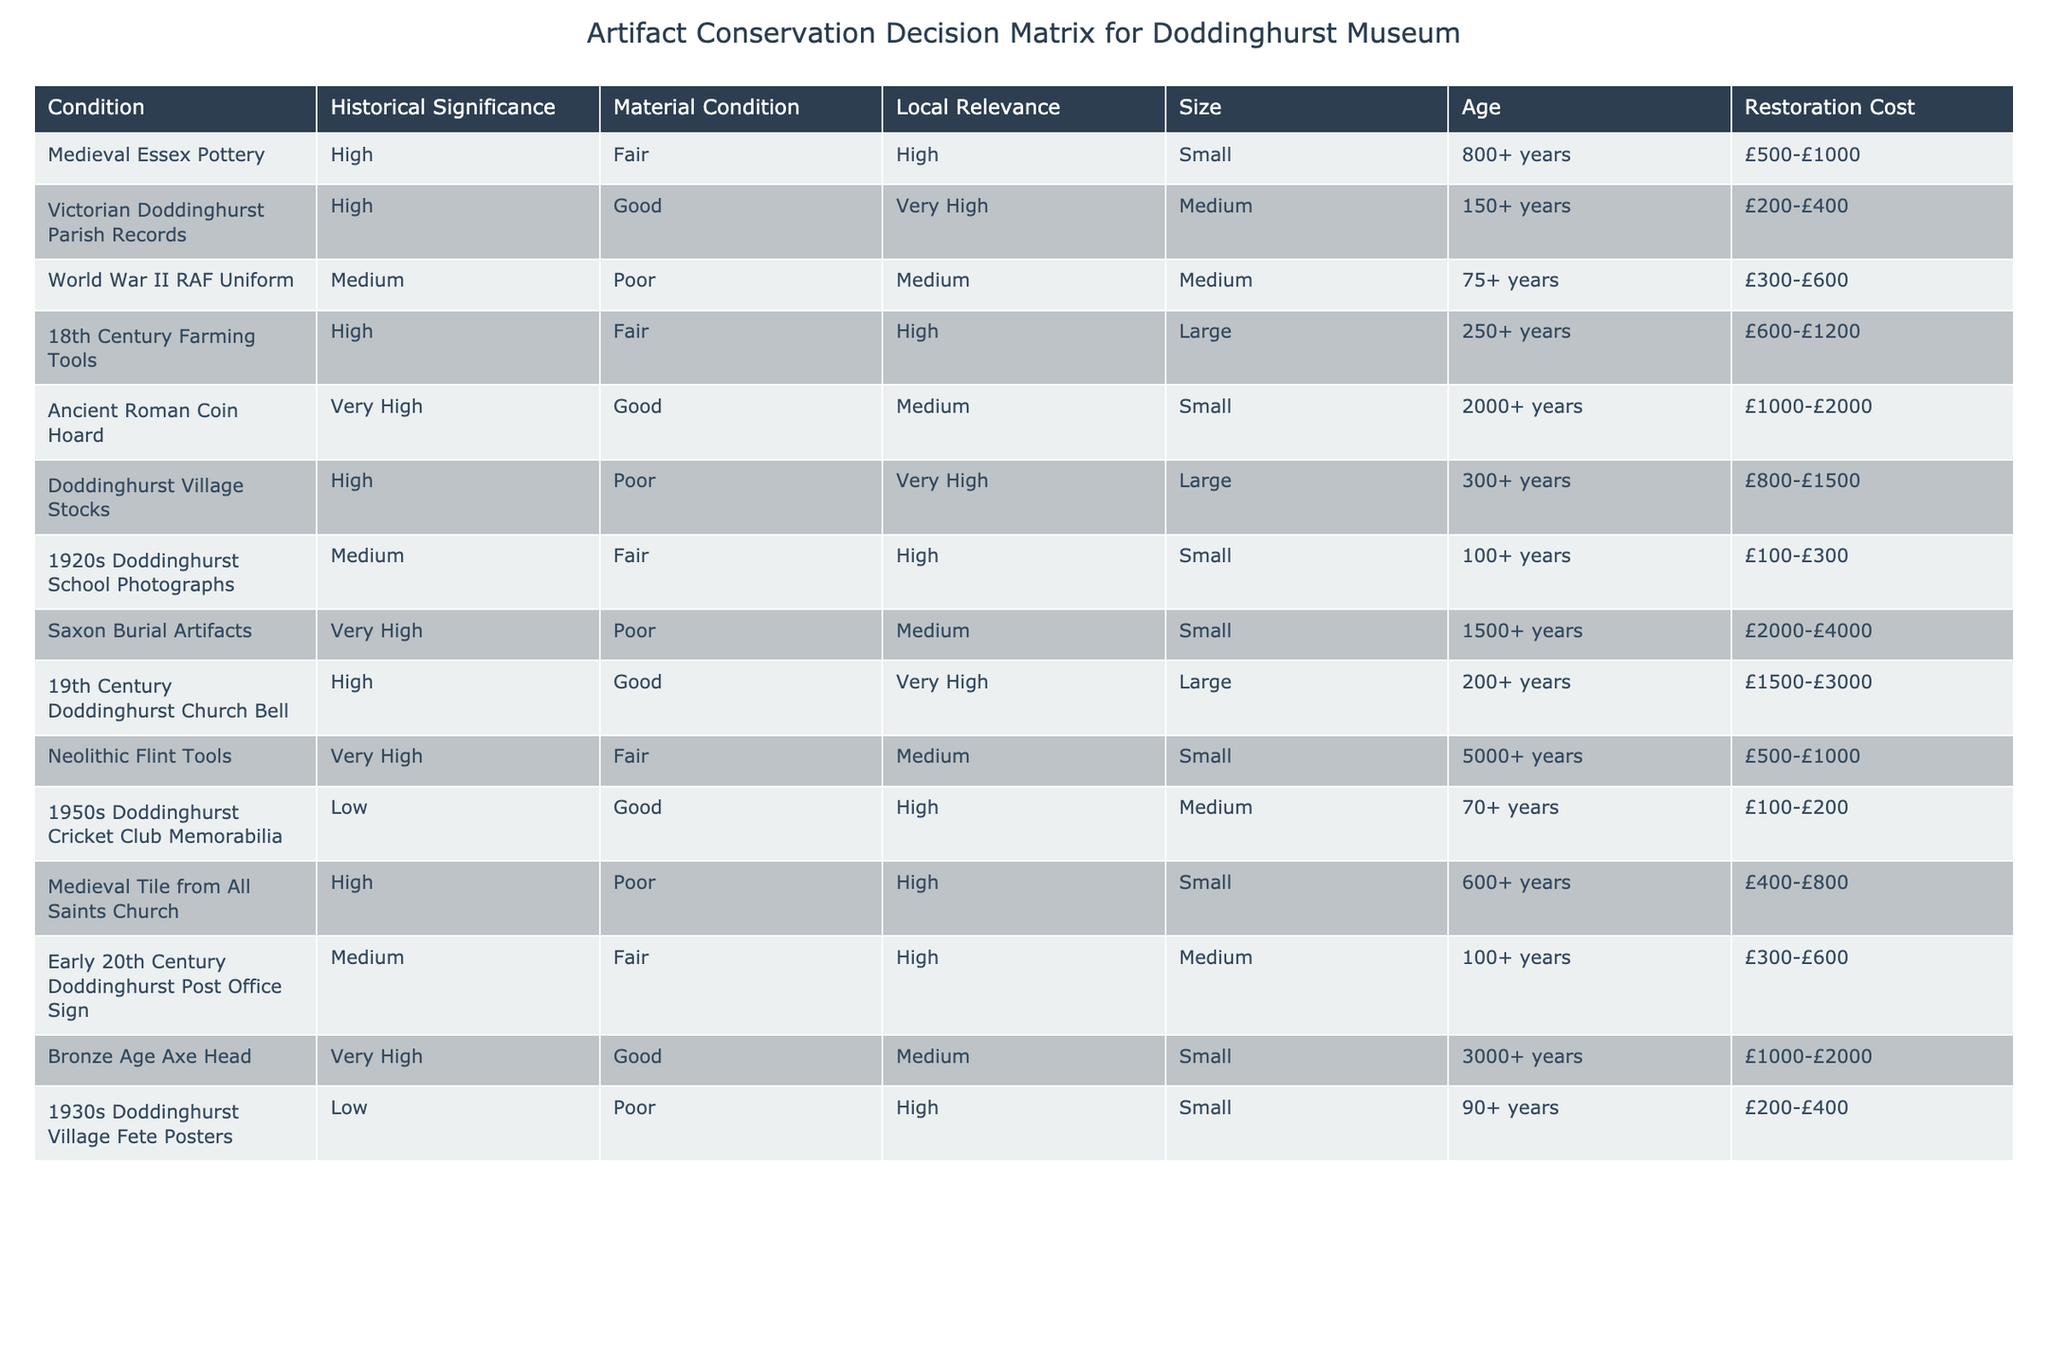What is the age of the Ancient Roman Coin Hoard? The age of the Ancient Roman Coin Hoard is listed as 2000+ years in the Age column.
Answer: 2000+ years Which artifact has the highest historical significance? The artifact with the highest historical significance is the Ancient Roman Coin Hoard, as it is categorized as Very High in the Historical Significance column.
Answer: Ancient Roman Coin Hoard What is the restoration cost range for the Doddinghurst Village Stocks? The restoration cost range for the Doddinghurst Village Stocks is £800-£1500, as specified in the Restoration Cost column.
Answer: £800-£1500 Is there any artifact with both Poor material condition and Very High local relevance? Yes, the Doddinghurst Village Stocks have Poor material condition and Very High local relevance.
Answer: Yes What is the average restoration cost of artifacts categorized as Very High historical significance? The restoration costs for the artifacts with Very High historical significance are as follows: Ancient Roman Coin Hoard (£1000-£2000), Saxon Burial Artifacts (£2000-£4000), Bronze Age Axe Head (£1000-£2000). To find the average, calculate the midpoints:  £1500, £3000, £1500. The total is £6000. Dividing by 3 gives £2000.
Answer: £2000 Which artifacts are categorized as Medium in Local Relevance? The artifacts categorized as Medium in Local Relevance are the World War II RAF Uniform, Ancient Roman Coin Hoard, Neolithic Flint Tools, and 1950s Doddinghurst Cricket Club Memorabilia.
Answer: 4 artifacts What is the total number of artifacts that are categorized as High in Historical Significance? The artifacts categorized as High in Historical Significance include Medieval Essex Pottery, Victorian Doddinghurst Parish Records, 18th Century Farming Tools, Doddinghurst Village Stocks, 19th Century Doddinghurst Church Bell, and Medieval Tile from All Saints Church. Counting these gives a total of 6 artifacts.
Answer: 6 How many artifacts have a size classified as Small? The artifacts classified as Small are: Medieval Essex Pottery, Ancient Roman Coin Hoard, Neolithic Flint Tools, 1920s Doddinghurst School Photographs, and Medieval Tile from All Saints Church. Counting these gives a total of 5 artifacts.
Answer: 5 Which artifact has the lowest restoration cost? The artifact with the lowest restoration cost is 1950s Doddinghurst Cricket Club Memorabilia, which ranges from £100-£200 in the Restoration Cost column.
Answer: 1950s Doddinghurst Cricket Club Memorabilia 